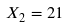<formula> <loc_0><loc_0><loc_500><loc_500>X _ { 2 } = 2 1</formula> 